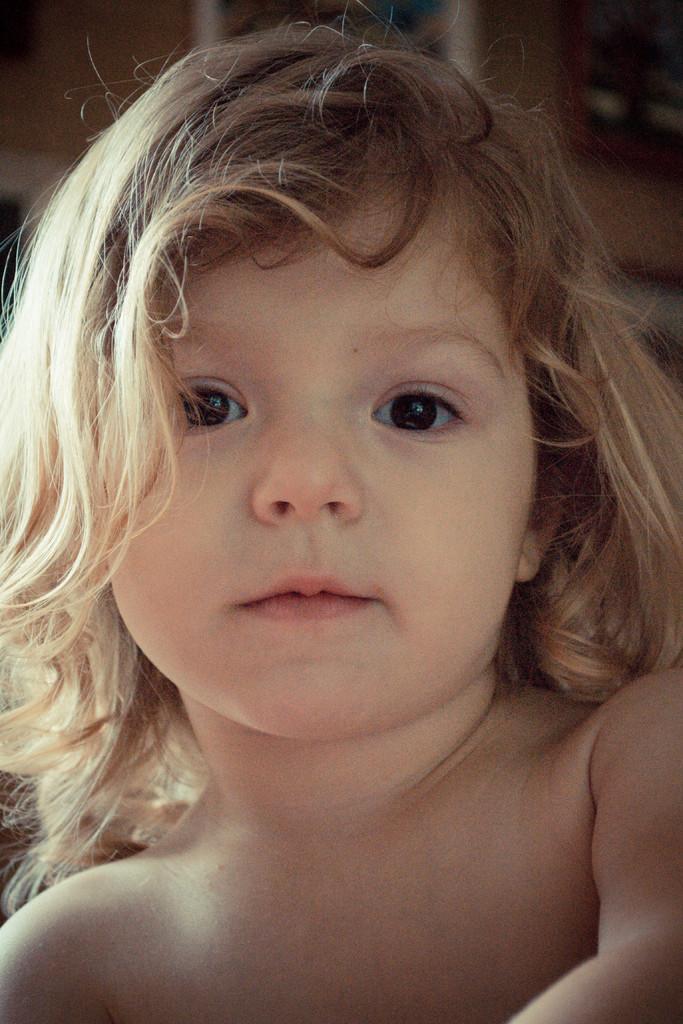Describe this image in one or two sentences. In this picture we can see a girl smiling and in the background it is blurry. 